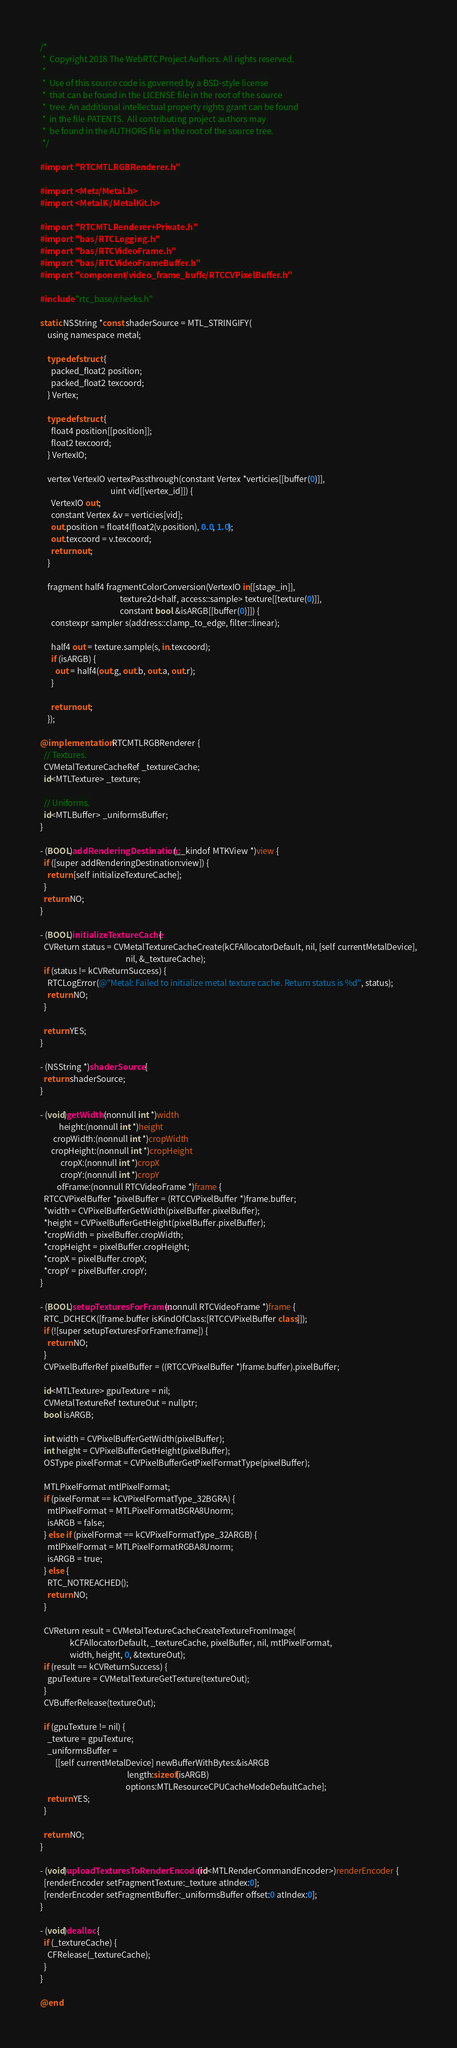<code> <loc_0><loc_0><loc_500><loc_500><_ObjectiveC_>/*
 *  Copyright 2018 The WebRTC Project Authors. All rights reserved.
 *
 *  Use of this source code is governed by a BSD-style license
 *  that can be found in the LICENSE file in the root of the source
 *  tree. An additional intellectual property rights grant can be found
 *  in the file PATENTS.  All contributing project authors may
 *  be found in the AUTHORS file in the root of the source tree.
 */

#import "RTCMTLRGBRenderer.h"

#import <Metal/Metal.h>
#import <MetalKit/MetalKit.h>

#import "RTCMTLRenderer+Private.h"
#import "base/RTCLogging.h"
#import "base/RTCVideoFrame.h"
#import "base/RTCVideoFrameBuffer.h"
#import "components/video_frame_buffer/RTCCVPixelBuffer.h"

#include "rtc_base/checks.h"

static NSString *const shaderSource = MTL_STRINGIFY(
    using namespace metal;

    typedef struct {
      packed_float2 position;
      packed_float2 texcoord;
    } Vertex;

    typedef struct {
      float4 position[[position]];
      float2 texcoord;
    } VertexIO;

    vertex VertexIO vertexPassthrough(constant Vertex *verticies[[buffer(0)]],
                                      uint vid[[vertex_id]]) {
      VertexIO out;
      constant Vertex &v = verticies[vid];
      out.position = float4(float2(v.position), 0.0, 1.0);
      out.texcoord = v.texcoord;
      return out;
    }

    fragment half4 fragmentColorConversion(VertexIO in[[stage_in]],
                                           texture2d<half, access::sample> texture[[texture(0)]],
                                           constant bool &isARGB[[buffer(0)]]) {
      constexpr sampler s(address::clamp_to_edge, filter::linear);

      half4 out = texture.sample(s, in.texcoord);
      if (isARGB) {
        out = half4(out.g, out.b, out.a, out.r);
      }

      return out;
    });

@implementation RTCMTLRGBRenderer {
  // Textures.
  CVMetalTextureCacheRef _textureCache;
  id<MTLTexture> _texture;

  // Uniforms.
  id<MTLBuffer> _uniformsBuffer;
}

- (BOOL)addRenderingDestination:(__kindof MTKView *)view {
  if ([super addRenderingDestination:view]) {
    return [self initializeTextureCache];
  }
  return NO;
}

- (BOOL)initializeTextureCache {
  CVReturn status = CVMetalTextureCacheCreate(kCFAllocatorDefault, nil, [self currentMetalDevice],
                                              nil, &_textureCache);
  if (status != kCVReturnSuccess) {
    RTCLogError(@"Metal: Failed to initialize metal texture cache. Return status is %d", status);
    return NO;
  }

  return YES;
}

- (NSString *)shaderSource {
  return shaderSource;
}

- (void)getWidth:(nonnull int *)width
          height:(nonnull int *)height
       cropWidth:(nonnull int *)cropWidth
      cropHeight:(nonnull int *)cropHeight
           cropX:(nonnull int *)cropX
           cropY:(nonnull int *)cropY
         ofFrame:(nonnull RTCVideoFrame *)frame {
  RTCCVPixelBuffer *pixelBuffer = (RTCCVPixelBuffer *)frame.buffer;
  *width = CVPixelBufferGetWidth(pixelBuffer.pixelBuffer);
  *height = CVPixelBufferGetHeight(pixelBuffer.pixelBuffer);
  *cropWidth = pixelBuffer.cropWidth;
  *cropHeight = pixelBuffer.cropHeight;
  *cropX = pixelBuffer.cropX;
  *cropY = pixelBuffer.cropY;
}

- (BOOL)setupTexturesForFrame:(nonnull RTCVideoFrame *)frame {
  RTC_DCHECK([frame.buffer isKindOfClass:[RTCCVPixelBuffer class]]);
  if (![super setupTexturesForFrame:frame]) {
    return NO;
  }
  CVPixelBufferRef pixelBuffer = ((RTCCVPixelBuffer *)frame.buffer).pixelBuffer;

  id<MTLTexture> gpuTexture = nil;
  CVMetalTextureRef textureOut = nullptr;
  bool isARGB;

  int width = CVPixelBufferGetWidth(pixelBuffer);
  int height = CVPixelBufferGetHeight(pixelBuffer);
  OSType pixelFormat = CVPixelBufferGetPixelFormatType(pixelBuffer);

  MTLPixelFormat mtlPixelFormat;
  if (pixelFormat == kCVPixelFormatType_32BGRA) {
    mtlPixelFormat = MTLPixelFormatBGRA8Unorm;
    isARGB = false;
  } else if (pixelFormat == kCVPixelFormatType_32ARGB) {
    mtlPixelFormat = MTLPixelFormatRGBA8Unorm;
    isARGB = true;
  } else {
    RTC_NOTREACHED();
    return NO;
  }

  CVReturn result = CVMetalTextureCacheCreateTextureFromImage(
                kCFAllocatorDefault, _textureCache, pixelBuffer, nil, mtlPixelFormat,
                width, height, 0, &textureOut);
  if (result == kCVReturnSuccess) {
    gpuTexture = CVMetalTextureGetTexture(textureOut);
  }
  CVBufferRelease(textureOut);

  if (gpuTexture != nil) {
    _texture = gpuTexture;
    _uniformsBuffer =
        [[self currentMetalDevice] newBufferWithBytes:&isARGB
                                               length:sizeof(isARGB)
                                              options:MTLResourceCPUCacheModeDefaultCache];
    return YES;
  }

  return NO;
}

- (void)uploadTexturesToRenderEncoder:(id<MTLRenderCommandEncoder>)renderEncoder {
  [renderEncoder setFragmentTexture:_texture atIndex:0];
  [renderEncoder setFragmentBuffer:_uniformsBuffer offset:0 atIndex:0];
}

- (void)dealloc {
  if (_textureCache) {
    CFRelease(_textureCache);
  }
}

@end
</code> 